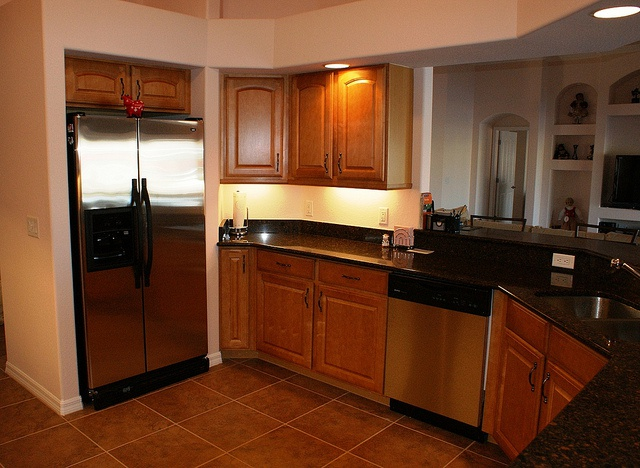Describe the objects in this image and their specific colors. I can see refrigerator in brown, black, maroon, and ivory tones, oven in brown, maroon, and black tones, sink in brown, black, maroon, and gray tones, tv in black, gray, maroon, and brown tones, and chair in brown, black, maroon, and gray tones in this image. 